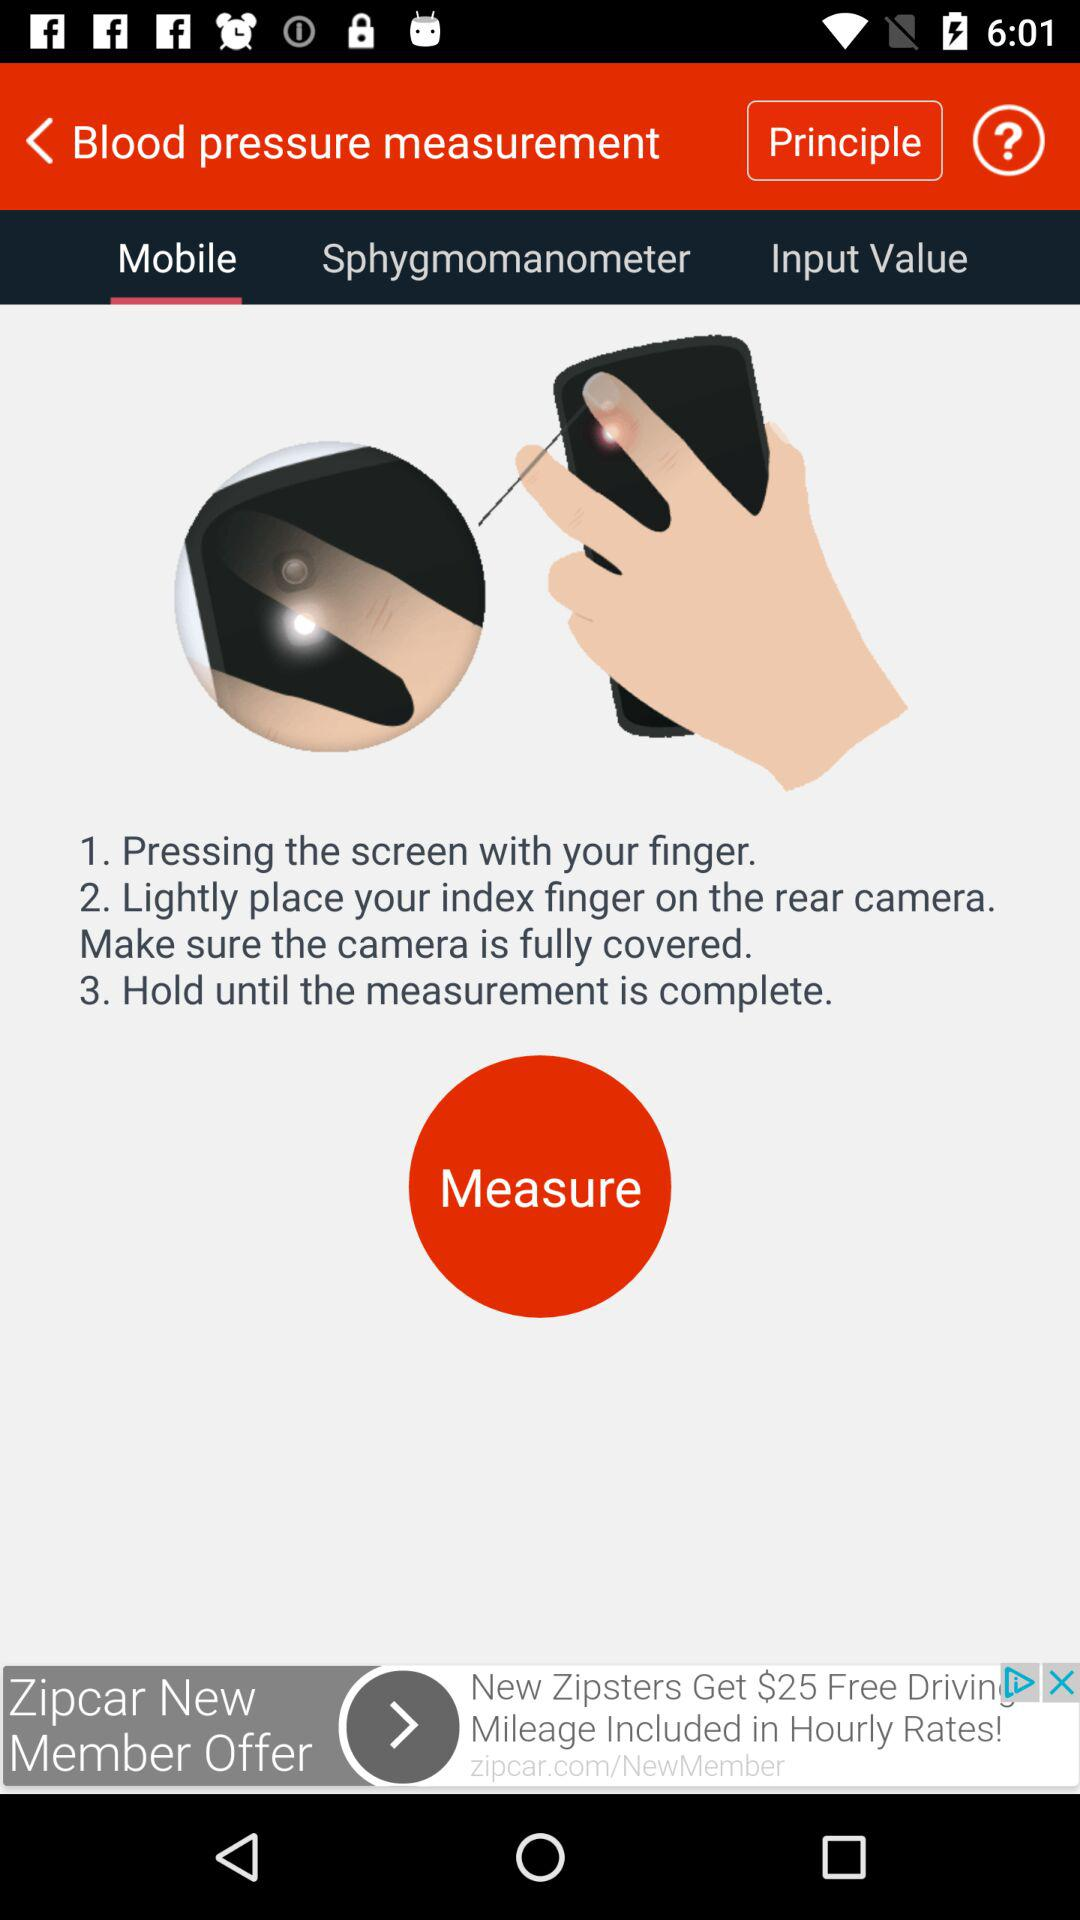Which tab am I on? You are on the "Mobile" tab. 